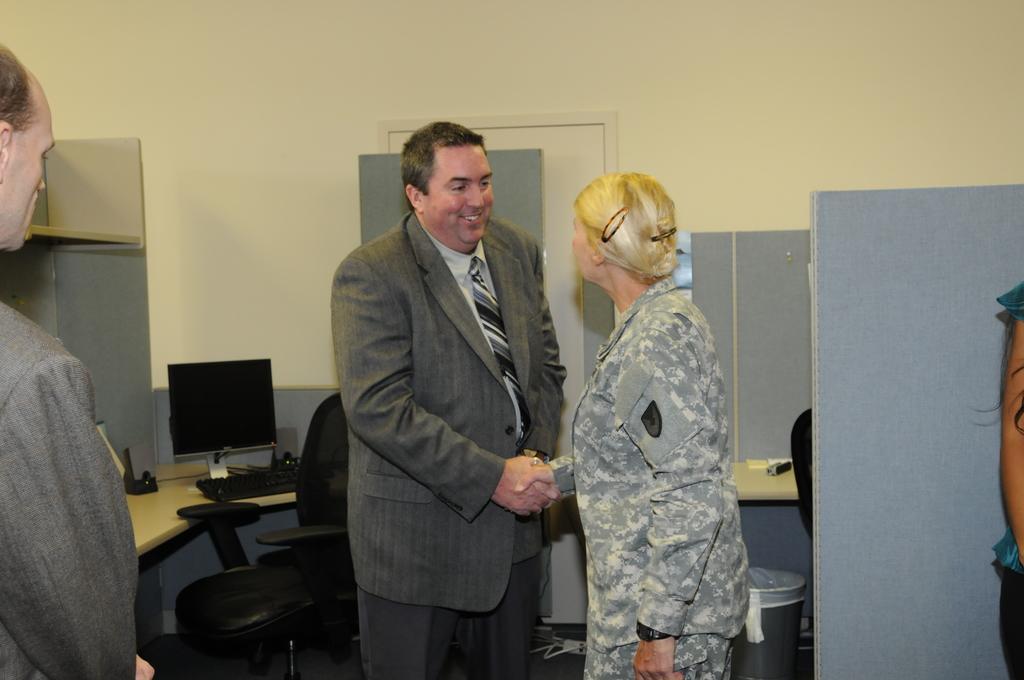Could you give a brief overview of what you see in this image? In this image in the center there are persons standing and shaking hands and the man is smiling. On the left side there is a person standing and in the background there is a monitor, keyboard, there is an empty chair and on the right side there is a woman standing and in the background there is a dustbin, door, and there is a wall. 